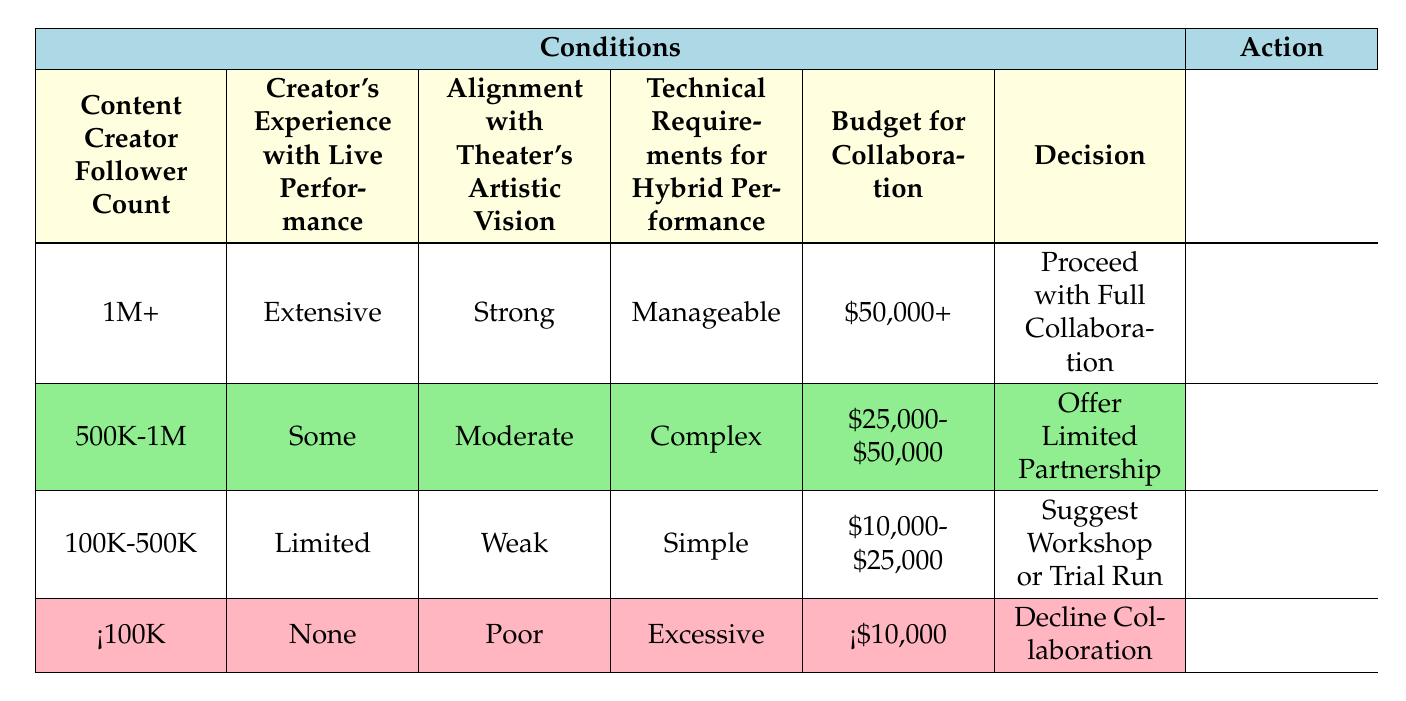What is the recommendation for a creator with a follower count of 1 million or more, extensive experience with live performance, strong alignment with the theater's vision, manageable technical requirements, and a budget of at least $50,000? According to the table, if a creator meets all those criteria, they fit into the first rule. This rule specifies that the recommendation is to "Proceed with Full Collaboration."
Answer: Proceed with Full Collaboration For a creator with a follower count between 500K and 1M and some experience with live performance, what budget range is appropriate? Referring to the second rule in the table, it states that the appropriate budget for this category of creators is between $25,000 and $50,000.
Answer: $25,000-$50,000 Is a creator with a follower count of 100K to 500K and limited experience likely to be offered a full collaboration? Based on the table, the specified conditions for this category do not include extensive experience or strong artistic alignment, hence they would not be eligible for a full collaboration. Thus, the answer is no.
Answer: No What is the relationship between a creator's budget and the suggested action if they have less than 100K followers and none of the live performance experience? The table suggests that for creators with less than 100K followers and no experience, their budget must be below $10,000, leading to the action of declining collaboration. Thus, the relationship indicates that inadequate budget and experience result in no collaboration.
Answer: Decline Collaboration Which action is recommended for a creator with a follower count of 18.2 million, limited live performance experience, weak alignment with the theater's vision, simple technical needs, and a proposed budget of $30,000? In this case, although the follower count suggests potential, the creator's limited experience, weak artistic alignment, and the simplicity of their technical needs align with the third rule that recommends suggesting a workshop or trial run.
Answer: Suggest Workshop or Trial Run How many total rules in the table suggest a partnership offer less than full collaboration? The table includes three rules: the second rule offers a limited partnership, the third rule suggests a workshop or trial run, and the last rule declines collaboration. Therefore, the total count of rules suggesting anything less than full collaboration is three.
Answer: 3 What are the main factors causing a creator to be excluded from collaboration altogether? The table indicates that if the creator has fewer than 100K followers, no experience, poor artistic alignment, and excessive technical needs alongside a budget below $10,000, they will be excluded from collaboration.
Answer: Poor alignment, budget, experience, and excessive needs Is it possible for a creator with a complex technical requirement and a budget of $50,000 to proceed with full collaboration? The rules in the table state that to recommend proceeding with full collaboration, other conditions must be fulfilled, specifically a budget of at least $50,000. Since the technical requirement is complex, and they do not meet the remaining conditions for full collaboration, the answer is no.
Answer: No 